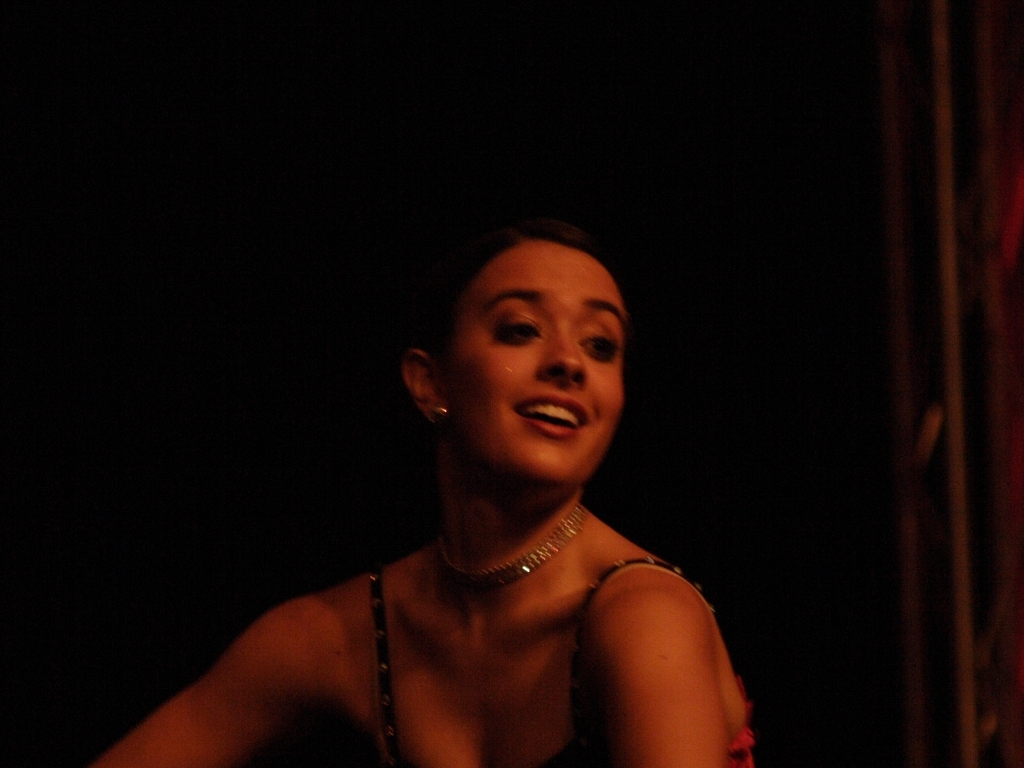Could you speculate on the possible event or occasion for this photograph? Based on the attire and visible part of the background suggesting a stage setting, it seems plausible that this photograph was taken during a dance recital or theatrical performance. What could be inferred about the person's role in the event? Given her costume and jewelry, it is likely that she is a performer, potentially a dancer, taking an active and prominent role in the event. 